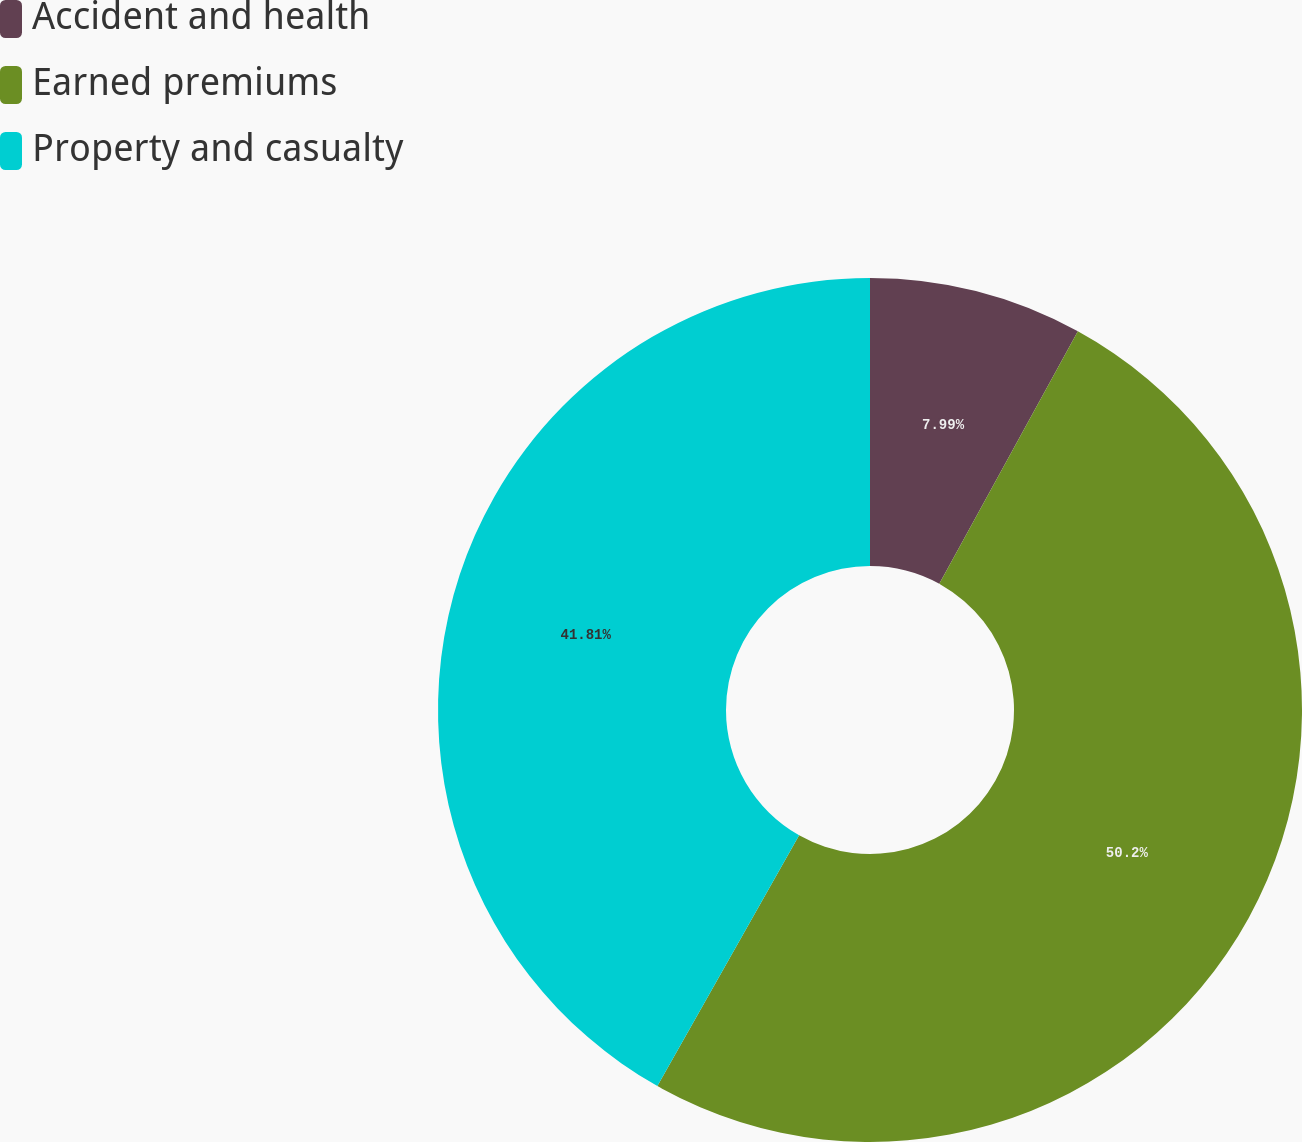Convert chart. <chart><loc_0><loc_0><loc_500><loc_500><pie_chart><fcel>Accident and health<fcel>Earned premiums<fcel>Property and casualty<nl><fcel>7.99%<fcel>50.2%<fcel>41.81%<nl></chart> 